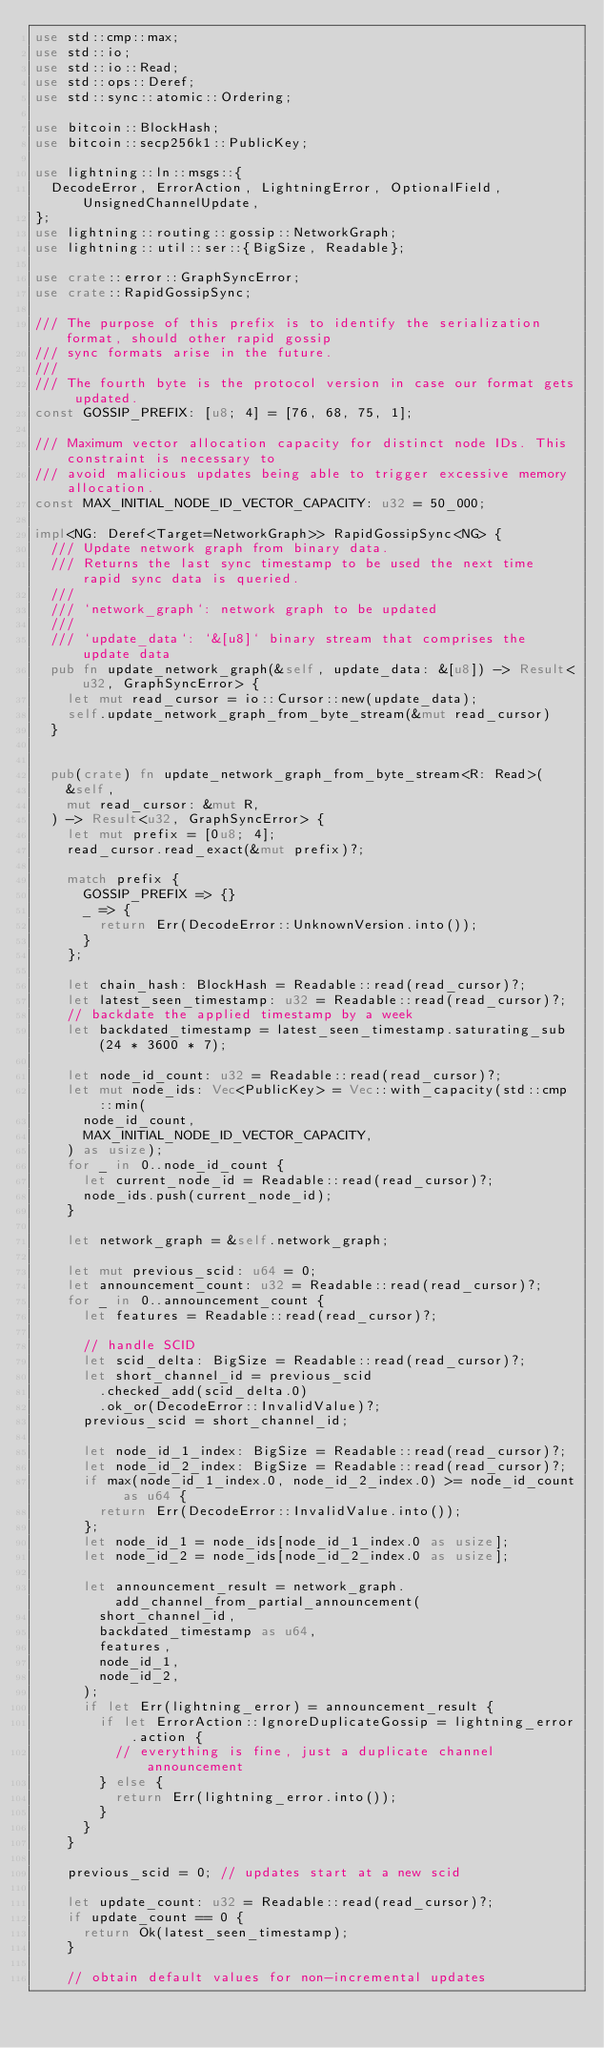<code> <loc_0><loc_0><loc_500><loc_500><_Rust_>use std::cmp::max;
use std::io;
use std::io::Read;
use std::ops::Deref;
use std::sync::atomic::Ordering;

use bitcoin::BlockHash;
use bitcoin::secp256k1::PublicKey;

use lightning::ln::msgs::{
	DecodeError, ErrorAction, LightningError, OptionalField, UnsignedChannelUpdate,
};
use lightning::routing::gossip::NetworkGraph;
use lightning::util::ser::{BigSize, Readable};

use crate::error::GraphSyncError;
use crate::RapidGossipSync;

/// The purpose of this prefix is to identify the serialization format, should other rapid gossip
/// sync formats arise in the future.
///
/// The fourth byte is the protocol version in case our format gets updated.
const GOSSIP_PREFIX: [u8; 4] = [76, 68, 75, 1];

/// Maximum vector allocation capacity for distinct node IDs. This constraint is necessary to
/// avoid malicious updates being able to trigger excessive memory allocation.
const MAX_INITIAL_NODE_ID_VECTOR_CAPACITY: u32 = 50_000;

impl<NG: Deref<Target=NetworkGraph>> RapidGossipSync<NG> {
	/// Update network graph from binary data.
	/// Returns the last sync timestamp to be used the next time rapid sync data is queried.
	///
	/// `network_graph`: network graph to be updated
	///
	/// `update_data`: `&[u8]` binary stream that comprises the update data
	pub fn update_network_graph(&self, update_data: &[u8]) -> Result<u32, GraphSyncError> {
		let mut read_cursor = io::Cursor::new(update_data);
		self.update_network_graph_from_byte_stream(&mut read_cursor)
	}


	pub(crate) fn update_network_graph_from_byte_stream<R: Read>(
		&self,
		mut read_cursor: &mut R,
	) -> Result<u32, GraphSyncError> {
		let mut prefix = [0u8; 4];
		read_cursor.read_exact(&mut prefix)?;

		match prefix {
			GOSSIP_PREFIX => {}
			_ => {
				return Err(DecodeError::UnknownVersion.into());
			}
		};

		let chain_hash: BlockHash = Readable::read(read_cursor)?;
		let latest_seen_timestamp: u32 = Readable::read(read_cursor)?;
		// backdate the applied timestamp by a week
		let backdated_timestamp = latest_seen_timestamp.saturating_sub(24 * 3600 * 7);

		let node_id_count: u32 = Readable::read(read_cursor)?;
		let mut node_ids: Vec<PublicKey> = Vec::with_capacity(std::cmp::min(
			node_id_count,
			MAX_INITIAL_NODE_ID_VECTOR_CAPACITY,
		) as usize);
		for _ in 0..node_id_count {
			let current_node_id = Readable::read(read_cursor)?;
			node_ids.push(current_node_id);
		}

		let network_graph = &self.network_graph;

		let mut previous_scid: u64 = 0;
		let announcement_count: u32 = Readable::read(read_cursor)?;
		for _ in 0..announcement_count {
			let features = Readable::read(read_cursor)?;

			// handle SCID
			let scid_delta: BigSize = Readable::read(read_cursor)?;
			let short_channel_id = previous_scid
				.checked_add(scid_delta.0)
				.ok_or(DecodeError::InvalidValue)?;
			previous_scid = short_channel_id;

			let node_id_1_index: BigSize = Readable::read(read_cursor)?;
			let node_id_2_index: BigSize = Readable::read(read_cursor)?;
			if max(node_id_1_index.0, node_id_2_index.0) >= node_id_count as u64 {
				return Err(DecodeError::InvalidValue.into());
			};
			let node_id_1 = node_ids[node_id_1_index.0 as usize];
			let node_id_2 = node_ids[node_id_2_index.0 as usize];

			let announcement_result = network_graph.add_channel_from_partial_announcement(
				short_channel_id,
				backdated_timestamp as u64,
				features,
				node_id_1,
				node_id_2,
			);
			if let Err(lightning_error) = announcement_result {
				if let ErrorAction::IgnoreDuplicateGossip = lightning_error.action {
					// everything is fine, just a duplicate channel announcement
				} else {
					return Err(lightning_error.into());
				}
			}
		}

		previous_scid = 0; // updates start at a new scid

		let update_count: u32 = Readable::read(read_cursor)?;
		if update_count == 0 {
			return Ok(latest_seen_timestamp);
		}

		// obtain default values for non-incremental updates</code> 